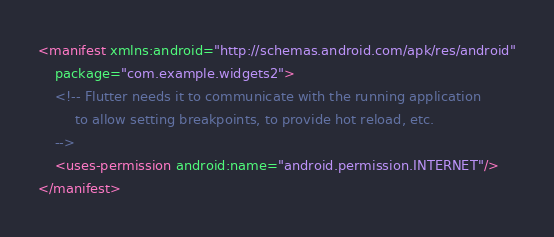Convert code to text. <code><loc_0><loc_0><loc_500><loc_500><_XML_><manifest xmlns:android="http://schemas.android.com/apk/res/android"
    package="com.example.widgets2">
    <!-- Flutter needs it to communicate with the running application
         to allow setting breakpoints, to provide hot reload, etc.
    -->
    <uses-permission android:name="android.permission.INTERNET"/>
</manifest>
</code> 